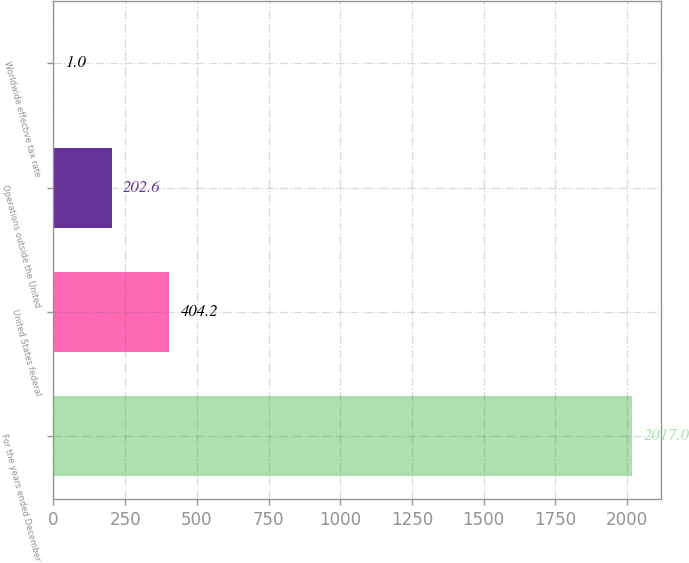Convert chart to OTSL. <chart><loc_0><loc_0><loc_500><loc_500><bar_chart><fcel>For the years ended December<fcel>United States federal<fcel>Operations outside the United<fcel>Worldwide effective tax rate<nl><fcel>2017<fcel>404.2<fcel>202.6<fcel>1<nl></chart> 